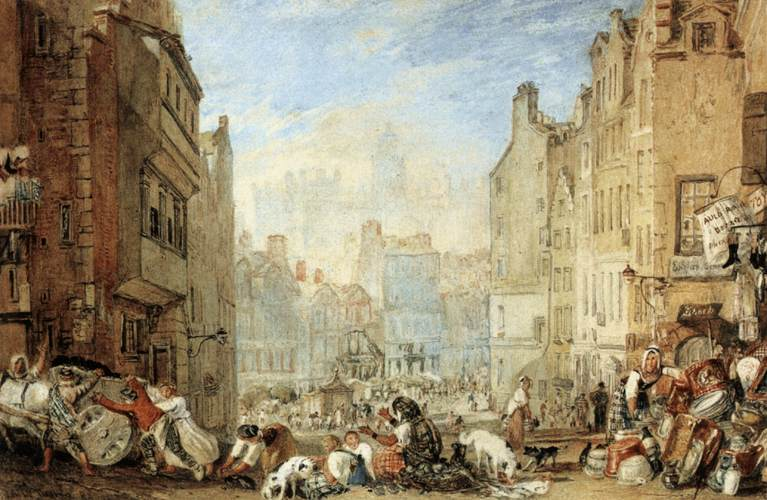What might be happening in the foreground of the painting? The foreground of the painting is alive with the hustle and bustle of a marketplace. People are gathered around vendors, examining goods that range from foodstuffs to textiles. Some individuals appear to be engaging in trade or barter, while others simply socialize or oversee their stalls. The clothing styles indicate varied social statuses, suggesting a dynamic interaction among different societal groups in this open market. 